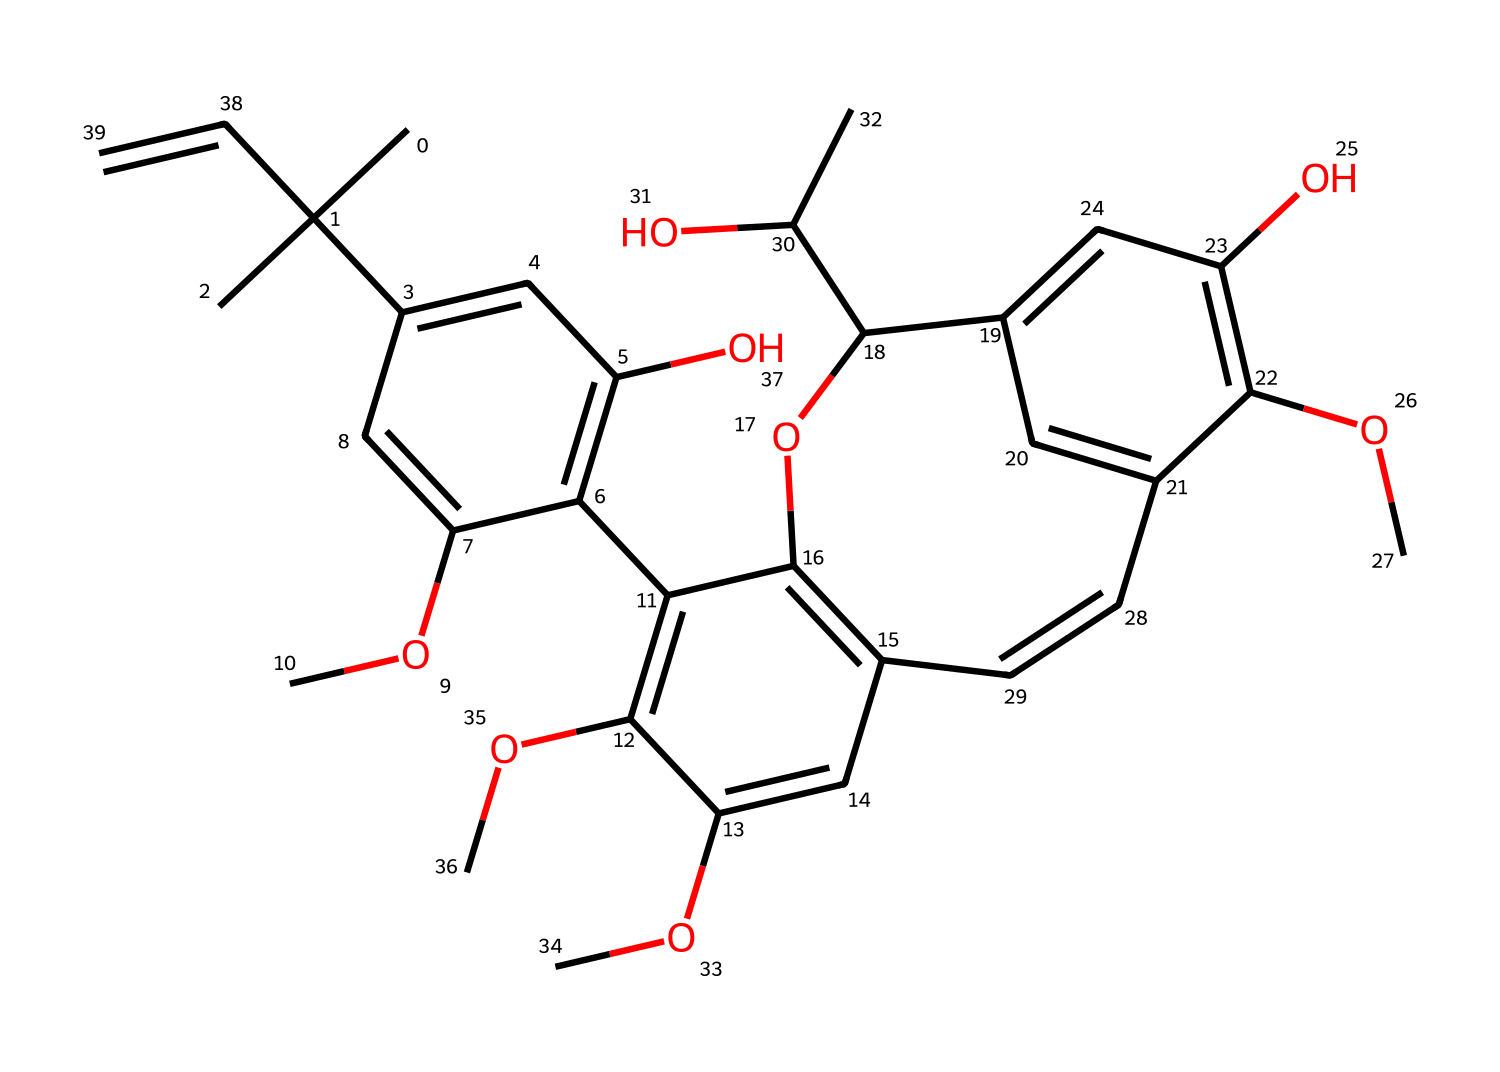What type of compound does this SMILES representation suggest? The SMILES notation indicates a compound that has multiple hydroxyl (–OH) groups and ether (–O–) linkages, both characteristic of phenolic compounds, which lignin is.
Answer: phenolic How many carbon atoms are present in the molecule represented by this SMILES? Count the number of "C" characters in the SMILES, which indicates the carbon atoms directly; after counting, there are 22 carbon atoms in total.
Answer: 22 What functional groups are evident in this structural representation? The structure contains hydroxyl (–OH) groups and ether (–O–) bonds, indicating the presence of alcohol and ether functional groups.
Answer: hydroxyl and ether What does the presence of multiple aromatic rings suggest about the properties of the substance? The presence of multiple aromatic rings indicates that the compound is likely to have significant stability and potentially unusual reactivity, often associated with strong intermolecular interactions.
Answer: stability How many hydroxyl groups are there in the molecule? To find the hydroxyl groups, look for "O" followed by a hydrogen or the structure that indicates the –OH functional group; there are five hydroxyl groups present.
Answer: 5 What type of linkage is primarily found in the structure based on the SMILES? The structure shows ether (-O-) linkages between various carbon atoms, indicative of a polymeric structure wherein units are connected by these types of linkages.
Answer: ether In what way might the structure influence the mechanical properties of traditional Dutch timber? The presence of such complex and interconnected structures like lignin contributes to the tensile strength and rigidity of wood, making it suitable for traditional clog making.
Answer: tensile strength 